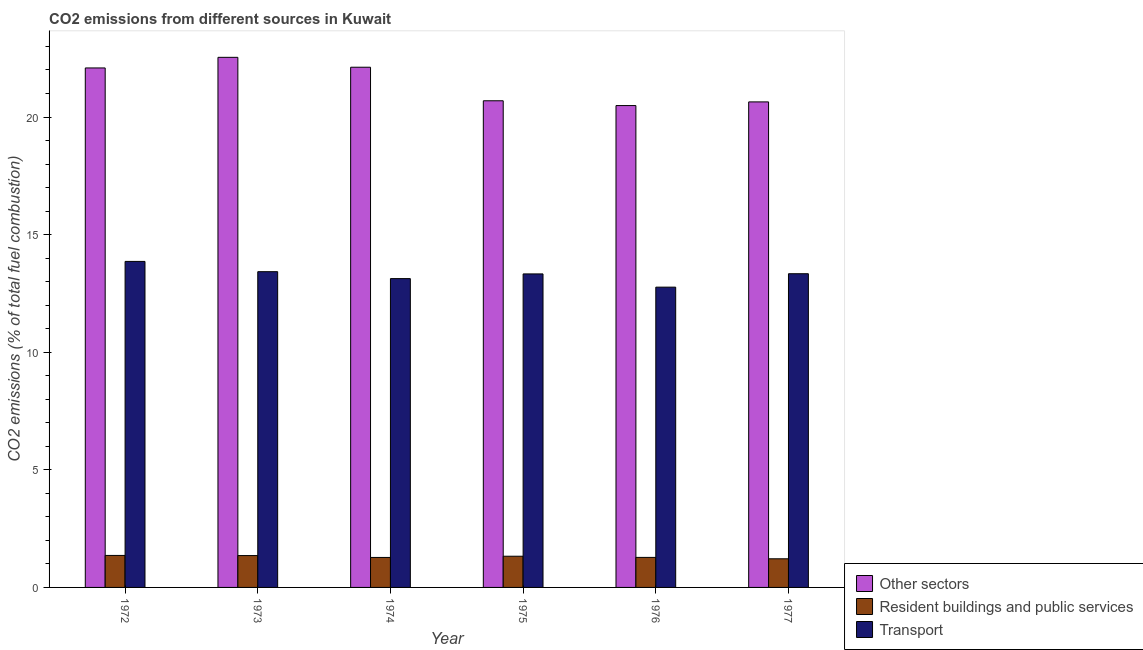How many different coloured bars are there?
Make the answer very short. 3. Are the number of bars per tick equal to the number of legend labels?
Offer a very short reply. Yes. How many bars are there on the 6th tick from the right?
Keep it short and to the point. 3. What is the label of the 4th group of bars from the left?
Make the answer very short. 1975. What is the percentage of co2 emissions from transport in 1977?
Your answer should be very brief. 13.34. Across all years, what is the maximum percentage of co2 emissions from transport?
Your answer should be very brief. 13.86. Across all years, what is the minimum percentage of co2 emissions from other sectors?
Offer a very short reply. 20.49. In which year was the percentage of co2 emissions from transport maximum?
Provide a succinct answer. 1972. In which year was the percentage of co2 emissions from other sectors minimum?
Your answer should be very brief. 1976. What is the total percentage of co2 emissions from other sectors in the graph?
Offer a terse response. 128.56. What is the difference between the percentage of co2 emissions from resident buildings and public services in 1973 and that in 1977?
Give a very brief answer. 0.14. What is the difference between the percentage of co2 emissions from resident buildings and public services in 1974 and the percentage of co2 emissions from transport in 1972?
Your response must be concise. -0.09. What is the average percentage of co2 emissions from resident buildings and public services per year?
Make the answer very short. 1.3. In how many years, is the percentage of co2 emissions from other sectors greater than 14 %?
Ensure brevity in your answer.  6. What is the ratio of the percentage of co2 emissions from transport in 1974 to that in 1976?
Ensure brevity in your answer.  1.03. Is the percentage of co2 emissions from other sectors in 1972 less than that in 1977?
Make the answer very short. No. What is the difference between the highest and the second highest percentage of co2 emissions from other sectors?
Offer a very short reply. 0.42. What is the difference between the highest and the lowest percentage of co2 emissions from resident buildings and public services?
Keep it short and to the point. 0.14. What does the 3rd bar from the left in 1974 represents?
Make the answer very short. Transport. What does the 1st bar from the right in 1973 represents?
Offer a very short reply. Transport. Is it the case that in every year, the sum of the percentage of co2 emissions from other sectors and percentage of co2 emissions from resident buildings and public services is greater than the percentage of co2 emissions from transport?
Provide a succinct answer. Yes. Are all the bars in the graph horizontal?
Ensure brevity in your answer.  No. How many years are there in the graph?
Keep it short and to the point. 6. What is the difference between two consecutive major ticks on the Y-axis?
Your answer should be compact. 5. Where does the legend appear in the graph?
Keep it short and to the point. Bottom right. What is the title of the graph?
Make the answer very short. CO2 emissions from different sources in Kuwait. What is the label or title of the Y-axis?
Keep it short and to the point. CO2 emissions (% of total fuel combustion). What is the CO2 emissions (% of total fuel combustion) of Other sectors in 1972?
Keep it short and to the point. 22.09. What is the CO2 emissions (% of total fuel combustion) of Resident buildings and public services in 1972?
Your answer should be compact. 1.36. What is the CO2 emissions (% of total fuel combustion) of Transport in 1972?
Your answer should be very brief. 13.86. What is the CO2 emissions (% of total fuel combustion) of Other sectors in 1973?
Keep it short and to the point. 22.54. What is the CO2 emissions (% of total fuel combustion) of Resident buildings and public services in 1973?
Provide a succinct answer. 1.35. What is the CO2 emissions (% of total fuel combustion) of Transport in 1973?
Make the answer very short. 13.42. What is the CO2 emissions (% of total fuel combustion) of Other sectors in 1974?
Give a very brief answer. 22.12. What is the CO2 emissions (% of total fuel combustion) of Resident buildings and public services in 1974?
Ensure brevity in your answer.  1.27. What is the CO2 emissions (% of total fuel combustion) of Transport in 1974?
Offer a very short reply. 13.13. What is the CO2 emissions (% of total fuel combustion) in Other sectors in 1975?
Provide a short and direct response. 20.69. What is the CO2 emissions (% of total fuel combustion) in Resident buildings and public services in 1975?
Give a very brief answer. 1.33. What is the CO2 emissions (% of total fuel combustion) in Transport in 1975?
Your answer should be compact. 13.33. What is the CO2 emissions (% of total fuel combustion) in Other sectors in 1976?
Give a very brief answer. 20.49. What is the CO2 emissions (% of total fuel combustion) of Resident buildings and public services in 1976?
Your response must be concise. 1.28. What is the CO2 emissions (% of total fuel combustion) of Transport in 1976?
Ensure brevity in your answer.  12.77. What is the CO2 emissions (% of total fuel combustion) of Other sectors in 1977?
Ensure brevity in your answer.  20.64. What is the CO2 emissions (% of total fuel combustion) of Resident buildings and public services in 1977?
Offer a very short reply. 1.22. What is the CO2 emissions (% of total fuel combustion) in Transport in 1977?
Keep it short and to the point. 13.34. Across all years, what is the maximum CO2 emissions (% of total fuel combustion) of Other sectors?
Offer a very short reply. 22.54. Across all years, what is the maximum CO2 emissions (% of total fuel combustion) of Resident buildings and public services?
Offer a very short reply. 1.36. Across all years, what is the maximum CO2 emissions (% of total fuel combustion) in Transport?
Give a very brief answer. 13.86. Across all years, what is the minimum CO2 emissions (% of total fuel combustion) in Other sectors?
Ensure brevity in your answer.  20.49. Across all years, what is the minimum CO2 emissions (% of total fuel combustion) of Resident buildings and public services?
Provide a succinct answer. 1.22. Across all years, what is the minimum CO2 emissions (% of total fuel combustion) in Transport?
Your response must be concise. 12.77. What is the total CO2 emissions (% of total fuel combustion) in Other sectors in the graph?
Make the answer very short. 128.56. What is the total CO2 emissions (% of total fuel combustion) of Resident buildings and public services in the graph?
Make the answer very short. 7.81. What is the total CO2 emissions (% of total fuel combustion) of Transport in the graph?
Provide a short and direct response. 79.84. What is the difference between the CO2 emissions (% of total fuel combustion) in Other sectors in 1972 and that in 1973?
Ensure brevity in your answer.  -0.45. What is the difference between the CO2 emissions (% of total fuel combustion) of Resident buildings and public services in 1972 and that in 1973?
Your answer should be compact. 0.01. What is the difference between the CO2 emissions (% of total fuel combustion) of Transport in 1972 and that in 1973?
Give a very brief answer. 0.44. What is the difference between the CO2 emissions (% of total fuel combustion) in Other sectors in 1972 and that in 1974?
Your answer should be very brief. -0.03. What is the difference between the CO2 emissions (% of total fuel combustion) of Resident buildings and public services in 1972 and that in 1974?
Your response must be concise. 0.09. What is the difference between the CO2 emissions (% of total fuel combustion) of Transport in 1972 and that in 1974?
Ensure brevity in your answer.  0.73. What is the difference between the CO2 emissions (% of total fuel combustion) of Other sectors in 1972 and that in 1975?
Your answer should be very brief. 1.4. What is the difference between the CO2 emissions (% of total fuel combustion) in Resident buildings and public services in 1972 and that in 1975?
Your answer should be very brief. 0.03. What is the difference between the CO2 emissions (% of total fuel combustion) of Transport in 1972 and that in 1975?
Offer a terse response. 0.53. What is the difference between the CO2 emissions (% of total fuel combustion) of Other sectors in 1972 and that in 1976?
Keep it short and to the point. 1.6. What is the difference between the CO2 emissions (% of total fuel combustion) of Resident buildings and public services in 1972 and that in 1976?
Provide a short and direct response. 0.08. What is the difference between the CO2 emissions (% of total fuel combustion) of Transport in 1972 and that in 1976?
Your response must be concise. 1.09. What is the difference between the CO2 emissions (% of total fuel combustion) of Other sectors in 1972 and that in 1977?
Offer a terse response. 1.44. What is the difference between the CO2 emissions (% of total fuel combustion) in Resident buildings and public services in 1972 and that in 1977?
Offer a very short reply. 0.14. What is the difference between the CO2 emissions (% of total fuel combustion) of Transport in 1972 and that in 1977?
Provide a short and direct response. 0.52. What is the difference between the CO2 emissions (% of total fuel combustion) in Other sectors in 1973 and that in 1974?
Keep it short and to the point. 0.42. What is the difference between the CO2 emissions (% of total fuel combustion) of Resident buildings and public services in 1973 and that in 1974?
Make the answer very short. 0.08. What is the difference between the CO2 emissions (% of total fuel combustion) of Transport in 1973 and that in 1974?
Your answer should be compact. 0.29. What is the difference between the CO2 emissions (% of total fuel combustion) in Other sectors in 1973 and that in 1975?
Ensure brevity in your answer.  1.85. What is the difference between the CO2 emissions (% of total fuel combustion) in Resident buildings and public services in 1973 and that in 1975?
Provide a succinct answer. 0.03. What is the difference between the CO2 emissions (% of total fuel combustion) in Transport in 1973 and that in 1975?
Offer a terse response. 0.09. What is the difference between the CO2 emissions (% of total fuel combustion) in Other sectors in 1973 and that in 1976?
Provide a succinct answer. 2.05. What is the difference between the CO2 emissions (% of total fuel combustion) of Resident buildings and public services in 1973 and that in 1976?
Offer a terse response. 0.08. What is the difference between the CO2 emissions (% of total fuel combustion) in Transport in 1973 and that in 1976?
Give a very brief answer. 0.66. What is the difference between the CO2 emissions (% of total fuel combustion) in Other sectors in 1973 and that in 1977?
Keep it short and to the point. 1.9. What is the difference between the CO2 emissions (% of total fuel combustion) in Resident buildings and public services in 1973 and that in 1977?
Your answer should be compact. 0.14. What is the difference between the CO2 emissions (% of total fuel combustion) in Transport in 1973 and that in 1977?
Your answer should be compact. 0.09. What is the difference between the CO2 emissions (% of total fuel combustion) of Other sectors in 1974 and that in 1975?
Your response must be concise. 1.43. What is the difference between the CO2 emissions (% of total fuel combustion) of Resident buildings and public services in 1974 and that in 1975?
Offer a very short reply. -0.05. What is the difference between the CO2 emissions (% of total fuel combustion) of Transport in 1974 and that in 1975?
Make the answer very short. -0.2. What is the difference between the CO2 emissions (% of total fuel combustion) of Other sectors in 1974 and that in 1976?
Offer a very short reply. 1.63. What is the difference between the CO2 emissions (% of total fuel combustion) in Resident buildings and public services in 1974 and that in 1976?
Your response must be concise. -0. What is the difference between the CO2 emissions (% of total fuel combustion) in Transport in 1974 and that in 1976?
Your answer should be very brief. 0.36. What is the difference between the CO2 emissions (% of total fuel combustion) of Other sectors in 1974 and that in 1977?
Provide a succinct answer. 1.47. What is the difference between the CO2 emissions (% of total fuel combustion) in Resident buildings and public services in 1974 and that in 1977?
Provide a short and direct response. 0.06. What is the difference between the CO2 emissions (% of total fuel combustion) of Transport in 1974 and that in 1977?
Keep it short and to the point. -0.21. What is the difference between the CO2 emissions (% of total fuel combustion) of Other sectors in 1975 and that in 1976?
Ensure brevity in your answer.  0.2. What is the difference between the CO2 emissions (% of total fuel combustion) of Resident buildings and public services in 1975 and that in 1976?
Your response must be concise. 0.05. What is the difference between the CO2 emissions (% of total fuel combustion) in Transport in 1975 and that in 1976?
Offer a terse response. 0.56. What is the difference between the CO2 emissions (% of total fuel combustion) in Other sectors in 1975 and that in 1977?
Your response must be concise. 0.05. What is the difference between the CO2 emissions (% of total fuel combustion) of Resident buildings and public services in 1975 and that in 1977?
Ensure brevity in your answer.  0.11. What is the difference between the CO2 emissions (% of total fuel combustion) of Transport in 1975 and that in 1977?
Your answer should be very brief. -0.01. What is the difference between the CO2 emissions (% of total fuel combustion) of Other sectors in 1976 and that in 1977?
Give a very brief answer. -0.16. What is the difference between the CO2 emissions (% of total fuel combustion) in Resident buildings and public services in 1976 and that in 1977?
Give a very brief answer. 0.06. What is the difference between the CO2 emissions (% of total fuel combustion) in Transport in 1976 and that in 1977?
Your answer should be compact. -0.57. What is the difference between the CO2 emissions (% of total fuel combustion) in Other sectors in 1972 and the CO2 emissions (% of total fuel combustion) in Resident buildings and public services in 1973?
Provide a short and direct response. 20.73. What is the difference between the CO2 emissions (% of total fuel combustion) of Other sectors in 1972 and the CO2 emissions (% of total fuel combustion) of Transport in 1973?
Provide a succinct answer. 8.66. What is the difference between the CO2 emissions (% of total fuel combustion) of Resident buildings and public services in 1972 and the CO2 emissions (% of total fuel combustion) of Transport in 1973?
Provide a short and direct response. -12.06. What is the difference between the CO2 emissions (% of total fuel combustion) of Other sectors in 1972 and the CO2 emissions (% of total fuel combustion) of Resident buildings and public services in 1974?
Make the answer very short. 20.81. What is the difference between the CO2 emissions (% of total fuel combustion) in Other sectors in 1972 and the CO2 emissions (% of total fuel combustion) in Transport in 1974?
Make the answer very short. 8.96. What is the difference between the CO2 emissions (% of total fuel combustion) in Resident buildings and public services in 1972 and the CO2 emissions (% of total fuel combustion) in Transport in 1974?
Offer a very short reply. -11.77. What is the difference between the CO2 emissions (% of total fuel combustion) in Other sectors in 1972 and the CO2 emissions (% of total fuel combustion) in Resident buildings and public services in 1975?
Provide a succinct answer. 20.76. What is the difference between the CO2 emissions (% of total fuel combustion) of Other sectors in 1972 and the CO2 emissions (% of total fuel combustion) of Transport in 1975?
Give a very brief answer. 8.76. What is the difference between the CO2 emissions (% of total fuel combustion) in Resident buildings and public services in 1972 and the CO2 emissions (% of total fuel combustion) in Transport in 1975?
Ensure brevity in your answer.  -11.97. What is the difference between the CO2 emissions (% of total fuel combustion) in Other sectors in 1972 and the CO2 emissions (% of total fuel combustion) in Resident buildings and public services in 1976?
Ensure brevity in your answer.  20.81. What is the difference between the CO2 emissions (% of total fuel combustion) of Other sectors in 1972 and the CO2 emissions (% of total fuel combustion) of Transport in 1976?
Give a very brief answer. 9.32. What is the difference between the CO2 emissions (% of total fuel combustion) of Resident buildings and public services in 1972 and the CO2 emissions (% of total fuel combustion) of Transport in 1976?
Keep it short and to the point. -11.41. What is the difference between the CO2 emissions (% of total fuel combustion) of Other sectors in 1972 and the CO2 emissions (% of total fuel combustion) of Resident buildings and public services in 1977?
Ensure brevity in your answer.  20.87. What is the difference between the CO2 emissions (% of total fuel combustion) in Other sectors in 1972 and the CO2 emissions (% of total fuel combustion) in Transport in 1977?
Offer a terse response. 8.75. What is the difference between the CO2 emissions (% of total fuel combustion) of Resident buildings and public services in 1972 and the CO2 emissions (% of total fuel combustion) of Transport in 1977?
Ensure brevity in your answer.  -11.98. What is the difference between the CO2 emissions (% of total fuel combustion) in Other sectors in 1973 and the CO2 emissions (% of total fuel combustion) in Resident buildings and public services in 1974?
Make the answer very short. 21.26. What is the difference between the CO2 emissions (% of total fuel combustion) in Other sectors in 1973 and the CO2 emissions (% of total fuel combustion) in Transport in 1974?
Offer a very short reply. 9.41. What is the difference between the CO2 emissions (% of total fuel combustion) in Resident buildings and public services in 1973 and the CO2 emissions (% of total fuel combustion) in Transport in 1974?
Your response must be concise. -11.77. What is the difference between the CO2 emissions (% of total fuel combustion) of Other sectors in 1973 and the CO2 emissions (% of total fuel combustion) of Resident buildings and public services in 1975?
Keep it short and to the point. 21.21. What is the difference between the CO2 emissions (% of total fuel combustion) in Other sectors in 1973 and the CO2 emissions (% of total fuel combustion) in Transport in 1975?
Your answer should be very brief. 9.21. What is the difference between the CO2 emissions (% of total fuel combustion) in Resident buildings and public services in 1973 and the CO2 emissions (% of total fuel combustion) in Transport in 1975?
Your response must be concise. -11.97. What is the difference between the CO2 emissions (% of total fuel combustion) in Other sectors in 1973 and the CO2 emissions (% of total fuel combustion) in Resident buildings and public services in 1976?
Ensure brevity in your answer.  21.26. What is the difference between the CO2 emissions (% of total fuel combustion) of Other sectors in 1973 and the CO2 emissions (% of total fuel combustion) of Transport in 1976?
Your response must be concise. 9.77. What is the difference between the CO2 emissions (% of total fuel combustion) of Resident buildings and public services in 1973 and the CO2 emissions (% of total fuel combustion) of Transport in 1976?
Ensure brevity in your answer.  -11.41. What is the difference between the CO2 emissions (% of total fuel combustion) in Other sectors in 1973 and the CO2 emissions (% of total fuel combustion) in Resident buildings and public services in 1977?
Keep it short and to the point. 21.32. What is the difference between the CO2 emissions (% of total fuel combustion) in Other sectors in 1973 and the CO2 emissions (% of total fuel combustion) in Transport in 1977?
Ensure brevity in your answer.  9.2. What is the difference between the CO2 emissions (% of total fuel combustion) of Resident buildings and public services in 1973 and the CO2 emissions (% of total fuel combustion) of Transport in 1977?
Ensure brevity in your answer.  -11.98. What is the difference between the CO2 emissions (% of total fuel combustion) of Other sectors in 1974 and the CO2 emissions (% of total fuel combustion) of Resident buildings and public services in 1975?
Offer a very short reply. 20.79. What is the difference between the CO2 emissions (% of total fuel combustion) in Other sectors in 1974 and the CO2 emissions (% of total fuel combustion) in Transport in 1975?
Keep it short and to the point. 8.79. What is the difference between the CO2 emissions (% of total fuel combustion) in Resident buildings and public services in 1974 and the CO2 emissions (% of total fuel combustion) in Transport in 1975?
Your answer should be very brief. -12.05. What is the difference between the CO2 emissions (% of total fuel combustion) in Other sectors in 1974 and the CO2 emissions (% of total fuel combustion) in Resident buildings and public services in 1976?
Offer a very short reply. 20.84. What is the difference between the CO2 emissions (% of total fuel combustion) in Other sectors in 1974 and the CO2 emissions (% of total fuel combustion) in Transport in 1976?
Your answer should be compact. 9.35. What is the difference between the CO2 emissions (% of total fuel combustion) in Resident buildings and public services in 1974 and the CO2 emissions (% of total fuel combustion) in Transport in 1976?
Ensure brevity in your answer.  -11.49. What is the difference between the CO2 emissions (% of total fuel combustion) in Other sectors in 1974 and the CO2 emissions (% of total fuel combustion) in Resident buildings and public services in 1977?
Give a very brief answer. 20.9. What is the difference between the CO2 emissions (% of total fuel combustion) of Other sectors in 1974 and the CO2 emissions (% of total fuel combustion) of Transport in 1977?
Keep it short and to the point. 8.78. What is the difference between the CO2 emissions (% of total fuel combustion) of Resident buildings and public services in 1974 and the CO2 emissions (% of total fuel combustion) of Transport in 1977?
Offer a very short reply. -12.06. What is the difference between the CO2 emissions (% of total fuel combustion) in Other sectors in 1975 and the CO2 emissions (% of total fuel combustion) in Resident buildings and public services in 1976?
Keep it short and to the point. 19.41. What is the difference between the CO2 emissions (% of total fuel combustion) of Other sectors in 1975 and the CO2 emissions (% of total fuel combustion) of Transport in 1976?
Provide a succinct answer. 7.92. What is the difference between the CO2 emissions (% of total fuel combustion) in Resident buildings and public services in 1975 and the CO2 emissions (% of total fuel combustion) in Transport in 1976?
Ensure brevity in your answer.  -11.44. What is the difference between the CO2 emissions (% of total fuel combustion) in Other sectors in 1975 and the CO2 emissions (% of total fuel combustion) in Resident buildings and public services in 1977?
Your answer should be very brief. 19.47. What is the difference between the CO2 emissions (% of total fuel combustion) in Other sectors in 1975 and the CO2 emissions (% of total fuel combustion) in Transport in 1977?
Provide a short and direct response. 7.35. What is the difference between the CO2 emissions (% of total fuel combustion) in Resident buildings and public services in 1975 and the CO2 emissions (% of total fuel combustion) in Transport in 1977?
Keep it short and to the point. -12.01. What is the difference between the CO2 emissions (% of total fuel combustion) in Other sectors in 1976 and the CO2 emissions (% of total fuel combustion) in Resident buildings and public services in 1977?
Make the answer very short. 19.27. What is the difference between the CO2 emissions (% of total fuel combustion) in Other sectors in 1976 and the CO2 emissions (% of total fuel combustion) in Transport in 1977?
Your response must be concise. 7.15. What is the difference between the CO2 emissions (% of total fuel combustion) in Resident buildings and public services in 1976 and the CO2 emissions (% of total fuel combustion) in Transport in 1977?
Keep it short and to the point. -12.06. What is the average CO2 emissions (% of total fuel combustion) in Other sectors per year?
Provide a succinct answer. 21.43. What is the average CO2 emissions (% of total fuel combustion) in Resident buildings and public services per year?
Make the answer very short. 1.3. What is the average CO2 emissions (% of total fuel combustion) in Transport per year?
Give a very brief answer. 13.31. In the year 1972, what is the difference between the CO2 emissions (% of total fuel combustion) in Other sectors and CO2 emissions (% of total fuel combustion) in Resident buildings and public services?
Provide a succinct answer. 20.73. In the year 1972, what is the difference between the CO2 emissions (% of total fuel combustion) in Other sectors and CO2 emissions (% of total fuel combustion) in Transport?
Ensure brevity in your answer.  8.23. In the year 1973, what is the difference between the CO2 emissions (% of total fuel combustion) of Other sectors and CO2 emissions (% of total fuel combustion) of Resident buildings and public services?
Provide a short and direct response. 21.18. In the year 1973, what is the difference between the CO2 emissions (% of total fuel combustion) of Other sectors and CO2 emissions (% of total fuel combustion) of Transport?
Offer a very short reply. 9.11. In the year 1973, what is the difference between the CO2 emissions (% of total fuel combustion) in Resident buildings and public services and CO2 emissions (% of total fuel combustion) in Transport?
Give a very brief answer. -12.07. In the year 1974, what is the difference between the CO2 emissions (% of total fuel combustion) of Other sectors and CO2 emissions (% of total fuel combustion) of Resident buildings and public services?
Your answer should be very brief. 20.84. In the year 1974, what is the difference between the CO2 emissions (% of total fuel combustion) of Other sectors and CO2 emissions (% of total fuel combustion) of Transport?
Offer a terse response. 8.99. In the year 1974, what is the difference between the CO2 emissions (% of total fuel combustion) of Resident buildings and public services and CO2 emissions (% of total fuel combustion) of Transport?
Your answer should be very brief. -11.85. In the year 1975, what is the difference between the CO2 emissions (% of total fuel combustion) in Other sectors and CO2 emissions (% of total fuel combustion) in Resident buildings and public services?
Your answer should be compact. 19.36. In the year 1975, what is the difference between the CO2 emissions (% of total fuel combustion) of Other sectors and CO2 emissions (% of total fuel combustion) of Transport?
Offer a terse response. 7.36. In the year 1975, what is the difference between the CO2 emissions (% of total fuel combustion) of Resident buildings and public services and CO2 emissions (% of total fuel combustion) of Transport?
Offer a terse response. -12. In the year 1976, what is the difference between the CO2 emissions (% of total fuel combustion) of Other sectors and CO2 emissions (% of total fuel combustion) of Resident buildings and public services?
Provide a short and direct response. 19.21. In the year 1976, what is the difference between the CO2 emissions (% of total fuel combustion) in Other sectors and CO2 emissions (% of total fuel combustion) in Transport?
Ensure brevity in your answer.  7.72. In the year 1976, what is the difference between the CO2 emissions (% of total fuel combustion) in Resident buildings and public services and CO2 emissions (% of total fuel combustion) in Transport?
Offer a terse response. -11.49. In the year 1977, what is the difference between the CO2 emissions (% of total fuel combustion) in Other sectors and CO2 emissions (% of total fuel combustion) in Resident buildings and public services?
Make the answer very short. 19.42. In the year 1977, what is the difference between the CO2 emissions (% of total fuel combustion) of Other sectors and CO2 emissions (% of total fuel combustion) of Transport?
Your answer should be very brief. 7.3. In the year 1977, what is the difference between the CO2 emissions (% of total fuel combustion) in Resident buildings and public services and CO2 emissions (% of total fuel combustion) in Transport?
Your answer should be compact. -12.12. What is the ratio of the CO2 emissions (% of total fuel combustion) of Other sectors in 1972 to that in 1973?
Provide a succinct answer. 0.98. What is the ratio of the CO2 emissions (% of total fuel combustion) in Resident buildings and public services in 1972 to that in 1973?
Give a very brief answer. 1. What is the ratio of the CO2 emissions (% of total fuel combustion) of Transport in 1972 to that in 1973?
Provide a succinct answer. 1.03. What is the ratio of the CO2 emissions (% of total fuel combustion) of Resident buildings and public services in 1972 to that in 1974?
Give a very brief answer. 1.07. What is the ratio of the CO2 emissions (% of total fuel combustion) in Transport in 1972 to that in 1974?
Make the answer very short. 1.06. What is the ratio of the CO2 emissions (% of total fuel combustion) of Other sectors in 1972 to that in 1975?
Provide a short and direct response. 1.07. What is the ratio of the CO2 emissions (% of total fuel combustion) of Resident buildings and public services in 1972 to that in 1975?
Ensure brevity in your answer.  1.03. What is the ratio of the CO2 emissions (% of total fuel combustion) of Transport in 1972 to that in 1975?
Offer a very short reply. 1.04. What is the ratio of the CO2 emissions (% of total fuel combustion) in Other sectors in 1972 to that in 1976?
Provide a short and direct response. 1.08. What is the ratio of the CO2 emissions (% of total fuel combustion) of Resident buildings and public services in 1972 to that in 1976?
Ensure brevity in your answer.  1.07. What is the ratio of the CO2 emissions (% of total fuel combustion) of Transport in 1972 to that in 1976?
Provide a succinct answer. 1.09. What is the ratio of the CO2 emissions (% of total fuel combustion) in Other sectors in 1972 to that in 1977?
Your answer should be very brief. 1.07. What is the ratio of the CO2 emissions (% of total fuel combustion) in Resident buildings and public services in 1972 to that in 1977?
Your answer should be very brief. 1.12. What is the ratio of the CO2 emissions (% of total fuel combustion) of Transport in 1972 to that in 1977?
Provide a short and direct response. 1.04. What is the ratio of the CO2 emissions (% of total fuel combustion) in Other sectors in 1973 to that in 1974?
Ensure brevity in your answer.  1.02. What is the ratio of the CO2 emissions (% of total fuel combustion) of Resident buildings and public services in 1973 to that in 1974?
Offer a terse response. 1.06. What is the ratio of the CO2 emissions (% of total fuel combustion) of Transport in 1973 to that in 1974?
Your response must be concise. 1.02. What is the ratio of the CO2 emissions (% of total fuel combustion) of Other sectors in 1973 to that in 1975?
Keep it short and to the point. 1.09. What is the ratio of the CO2 emissions (% of total fuel combustion) in Resident buildings and public services in 1973 to that in 1975?
Make the answer very short. 1.02. What is the ratio of the CO2 emissions (% of total fuel combustion) of Transport in 1973 to that in 1975?
Your answer should be very brief. 1.01. What is the ratio of the CO2 emissions (% of total fuel combustion) of Other sectors in 1973 to that in 1976?
Your answer should be compact. 1.1. What is the ratio of the CO2 emissions (% of total fuel combustion) in Resident buildings and public services in 1973 to that in 1976?
Your answer should be very brief. 1.06. What is the ratio of the CO2 emissions (% of total fuel combustion) in Transport in 1973 to that in 1976?
Provide a short and direct response. 1.05. What is the ratio of the CO2 emissions (% of total fuel combustion) of Other sectors in 1973 to that in 1977?
Your answer should be compact. 1.09. What is the ratio of the CO2 emissions (% of total fuel combustion) in Resident buildings and public services in 1973 to that in 1977?
Keep it short and to the point. 1.11. What is the ratio of the CO2 emissions (% of total fuel combustion) of Other sectors in 1974 to that in 1975?
Provide a succinct answer. 1.07. What is the ratio of the CO2 emissions (% of total fuel combustion) in Resident buildings and public services in 1974 to that in 1975?
Offer a very short reply. 0.96. What is the ratio of the CO2 emissions (% of total fuel combustion) of Transport in 1974 to that in 1975?
Ensure brevity in your answer.  0.98. What is the ratio of the CO2 emissions (% of total fuel combustion) in Other sectors in 1974 to that in 1976?
Your response must be concise. 1.08. What is the ratio of the CO2 emissions (% of total fuel combustion) of Resident buildings and public services in 1974 to that in 1976?
Ensure brevity in your answer.  1. What is the ratio of the CO2 emissions (% of total fuel combustion) of Transport in 1974 to that in 1976?
Your answer should be compact. 1.03. What is the ratio of the CO2 emissions (% of total fuel combustion) in Other sectors in 1974 to that in 1977?
Make the answer very short. 1.07. What is the ratio of the CO2 emissions (% of total fuel combustion) in Resident buildings and public services in 1974 to that in 1977?
Provide a succinct answer. 1.05. What is the ratio of the CO2 emissions (% of total fuel combustion) in Transport in 1974 to that in 1977?
Keep it short and to the point. 0.98. What is the ratio of the CO2 emissions (% of total fuel combustion) in Other sectors in 1975 to that in 1976?
Give a very brief answer. 1.01. What is the ratio of the CO2 emissions (% of total fuel combustion) of Resident buildings and public services in 1975 to that in 1976?
Provide a succinct answer. 1.04. What is the ratio of the CO2 emissions (% of total fuel combustion) in Transport in 1975 to that in 1976?
Your response must be concise. 1.04. What is the ratio of the CO2 emissions (% of total fuel combustion) in Resident buildings and public services in 1975 to that in 1977?
Your response must be concise. 1.09. What is the ratio of the CO2 emissions (% of total fuel combustion) of Other sectors in 1976 to that in 1977?
Keep it short and to the point. 0.99. What is the ratio of the CO2 emissions (% of total fuel combustion) of Resident buildings and public services in 1976 to that in 1977?
Make the answer very short. 1.05. What is the ratio of the CO2 emissions (% of total fuel combustion) in Transport in 1976 to that in 1977?
Your answer should be very brief. 0.96. What is the difference between the highest and the second highest CO2 emissions (% of total fuel combustion) in Other sectors?
Your answer should be compact. 0.42. What is the difference between the highest and the second highest CO2 emissions (% of total fuel combustion) of Resident buildings and public services?
Keep it short and to the point. 0.01. What is the difference between the highest and the second highest CO2 emissions (% of total fuel combustion) in Transport?
Your answer should be very brief. 0.44. What is the difference between the highest and the lowest CO2 emissions (% of total fuel combustion) in Other sectors?
Provide a short and direct response. 2.05. What is the difference between the highest and the lowest CO2 emissions (% of total fuel combustion) in Resident buildings and public services?
Your answer should be very brief. 0.14. What is the difference between the highest and the lowest CO2 emissions (% of total fuel combustion) of Transport?
Your answer should be very brief. 1.09. 